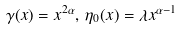Convert formula to latex. <formula><loc_0><loc_0><loc_500><loc_500>\gamma ( x ) = x ^ { 2 \alpha } , \, \eta _ { 0 } ( x ) = \lambda x ^ { \alpha - 1 }</formula> 